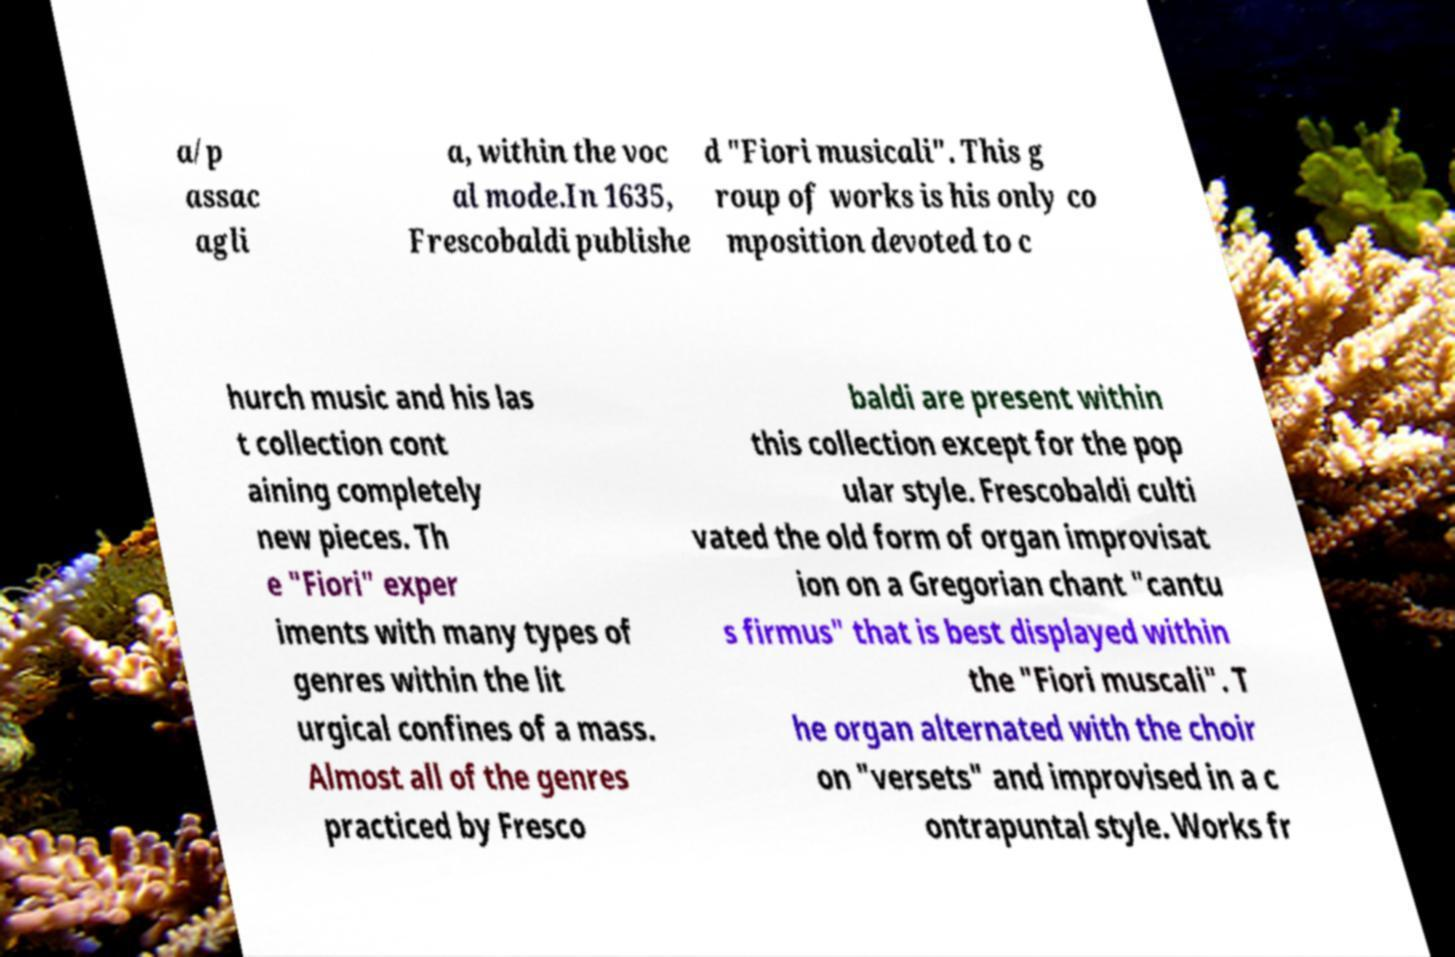For documentation purposes, I need the text within this image transcribed. Could you provide that? a/p assac agli a, within the voc al mode.In 1635, Frescobaldi publishe d "Fiori musicali". This g roup of works is his only co mposition devoted to c hurch music and his las t collection cont aining completely new pieces. Th e "Fiori" exper iments with many types of genres within the lit urgical confines of a mass. Almost all of the genres practiced by Fresco baldi are present within this collection except for the pop ular style. Frescobaldi culti vated the old form of organ improvisat ion on a Gregorian chant "cantu s firmus" that is best displayed within the "Fiori muscali". T he organ alternated with the choir on "versets" and improvised in a c ontrapuntal style. Works fr 